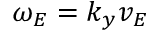Convert formula to latex. <formula><loc_0><loc_0><loc_500><loc_500>\omega _ { E } = k _ { y } v _ { E }</formula> 